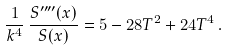Convert formula to latex. <formula><loc_0><loc_0><loc_500><loc_500>\frac { 1 } { k ^ { 4 } } \, \frac { S ^ { \prime \prime \prime \prime } ( x ) } { S ( x ) } = 5 - 2 8 T ^ { 2 } + 2 4 T ^ { 4 } \, .</formula> 